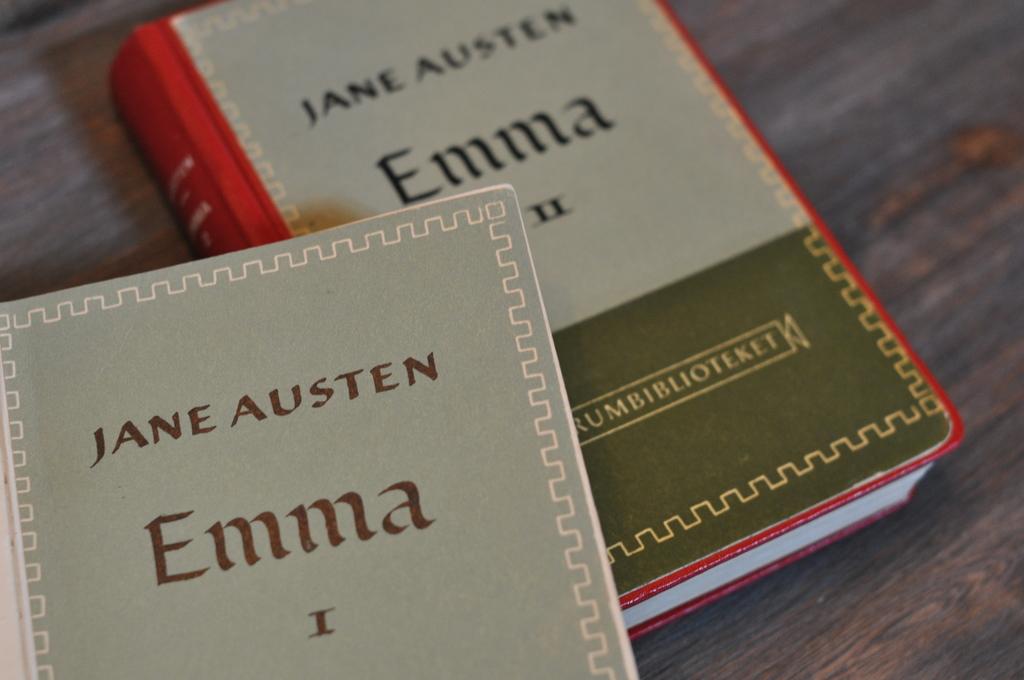What is the volume # of the top book?
Give a very brief answer. 1. 